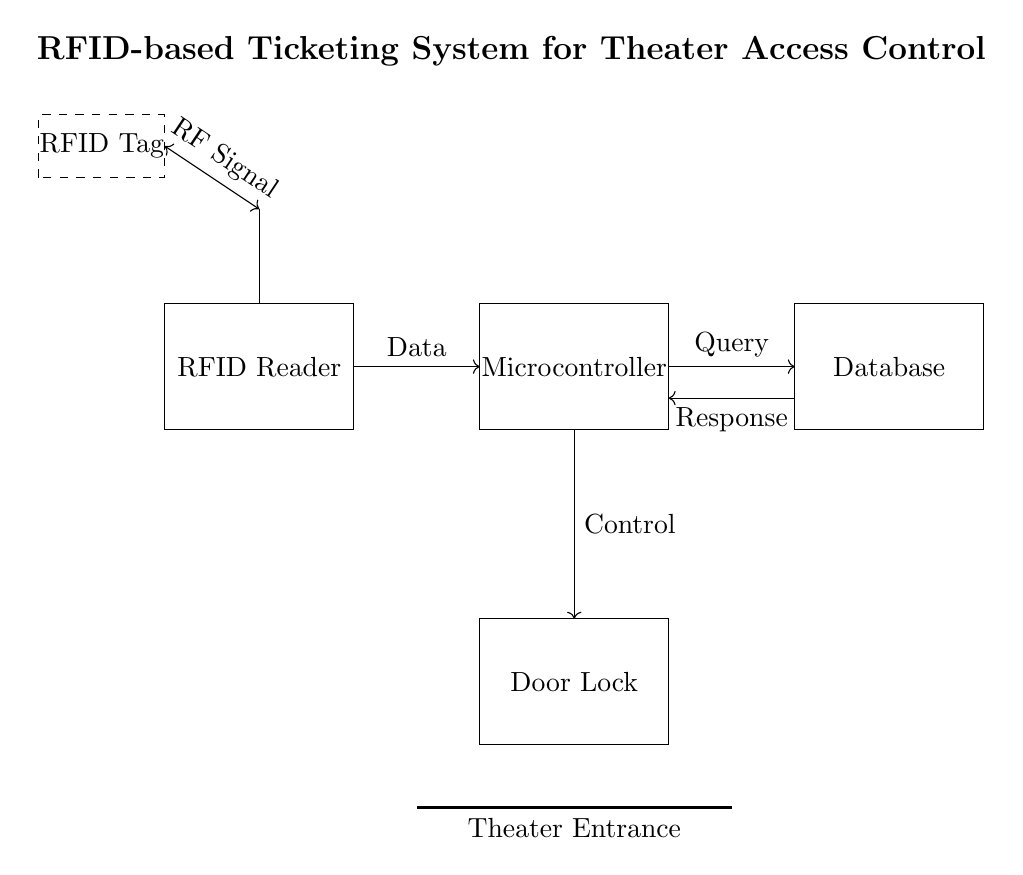What is the main component in the circuit? The main component in the circuit is the RFID Reader, which is responsible for reading the RFID Tags.
Answer: RFID Reader How many components are connected to the microcontroller? There are three components connected to the microcontroller: the RFID Reader, the Database, and the Door Lock.
Answer: Three What is the function of the database in this system? The Database stores ticket information and responds to queries from the microcontroller, allowing for access control based on the RFID Tags.
Answer: To store ticket information What type of signal is used between the RFID Tag and the RFID Reader? An RF signal is used for communication between the RFID Tag and the RFID Reader, indicated by the labeled arrow connecting the two components.
Answer: RF Signal What happens when a valid RFID Tag is detected? When a valid RFID Tag is detected, the RFID Reader sends data to the microcontroller, which processes it and controls the Door Lock based on the response from the Database.
Answer: Unlocks the door What is indicated by the dashed rectangle in the diagram? The dashed rectangle represents the RFID Tag, which is a passive component used to carry the ticket information for verification by the RFID Reader.
Answer: RFID Tag How does the Door Lock receive control signals? The Door Lock receives control signals through a direct connection from the microcontroller, which determines whether to lock or unlock the door based on the ticket validation status.
Answer: Through microcontroller connection 